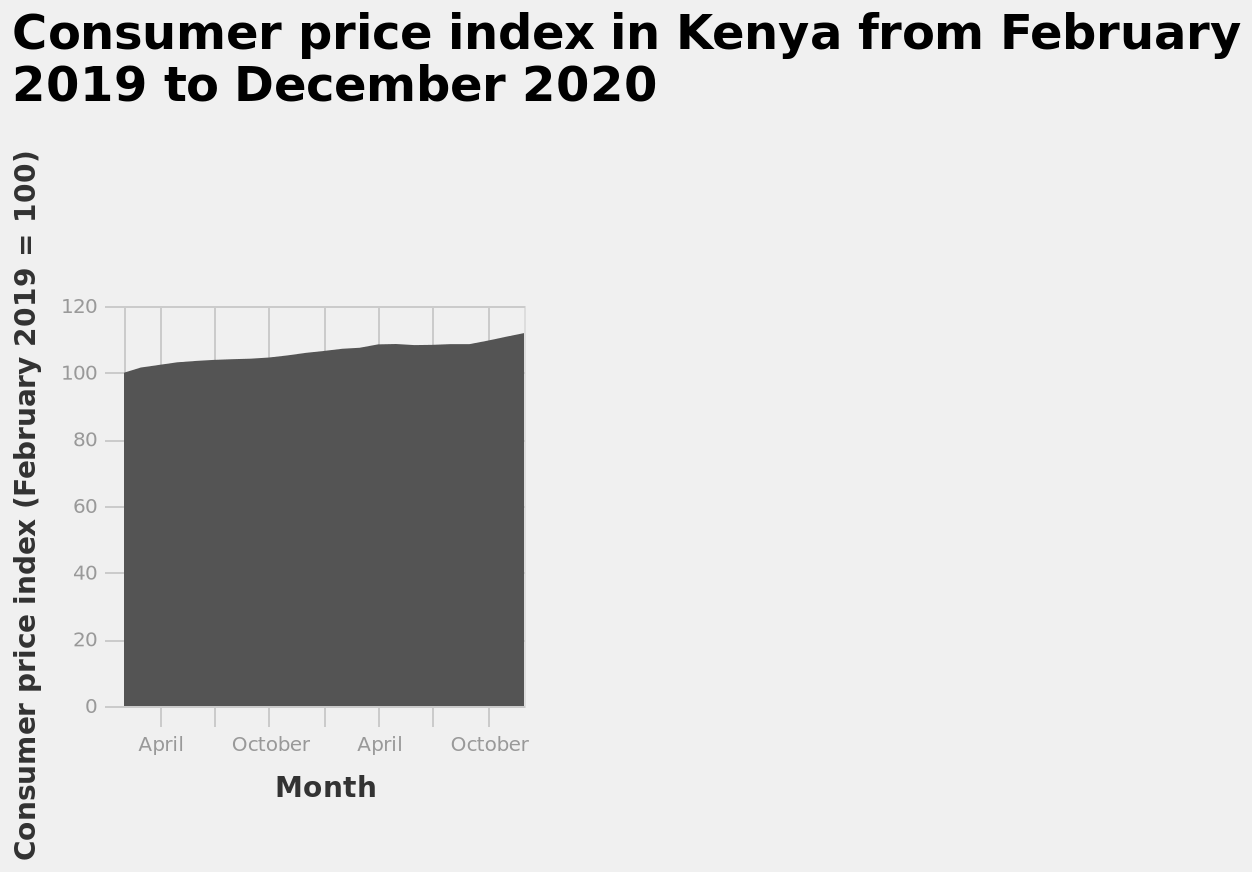<image>
What does the x-axis represent? The x-axis represents the month on a categorical scale, starting from April and ending at October. What was the starting value of the Consumer Price Index (CPI) in Kenya in February 2019? The starting value of the Consumer Price Index (CPI) in Kenya in February 2019 was 100. 